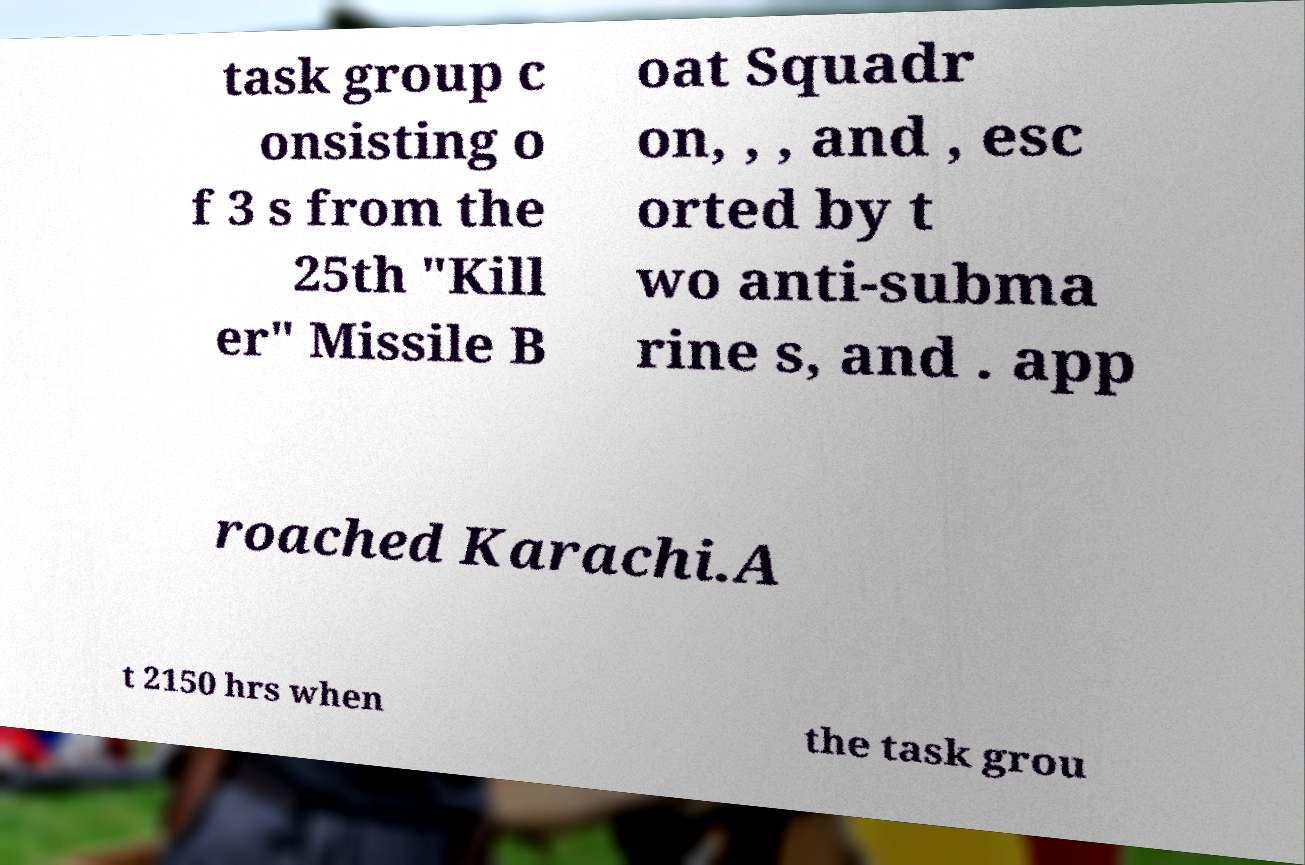Can you accurately transcribe the text from the provided image for me? task group c onsisting o f 3 s from the 25th "Kill er" Missile B oat Squadr on, , , and , esc orted by t wo anti-subma rine s, and . app roached Karachi.A t 2150 hrs when the task grou 